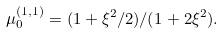<formula> <loc_0><loc_0><loc_500><loc_500>\mu ^ { ( 1 , 1 ) } _ { 0 } = ( 1 + \xi ^ { 2 } / 2 ) / ( 1 + 2 \xi ^ { 2 } ) .</formula> 